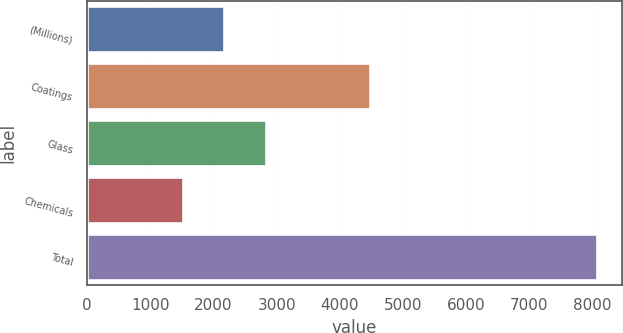<chart> <loc_0><loc_0><loc_500><loc_500><bar_chart><fcel>(Millions)<fcel>Coatings<fcel>Glass<fcel>Chemicals<fcel>Total<nl><fcel>2169.3<fcel>4482<fcel>2824.6<fcel>1514<fcel>8067<nl></chart> 